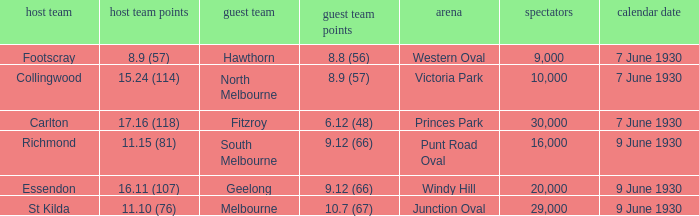Can you give me this table as a dict? {'header': ['host team', 'host team points', 'guest team', 'guest team points', 'arena', 'spectators', 'calendar date'], 'rows': [['Footscray', '8.9 (57)', 'Hawthorn', '8.8 (56)', 'Western Oval', '9,000', '7 June 1930'], ['Collingwood', '15.24 (114)', 'North Melbourne', '8.9 (57)', 'Victoria Park', '10,000', '7 June 1930'], ['Carlton', '17.16 (118)', 'Fitzroy', '6.12 (48)', 'Princes Park', '30,000', '7 June 1930'], ['Richmond', '11.15 (81)', 'South Melbourne', '9.12 (66)', 'Punt Road Oval', '16,000', '9 June 1930'], ['Essendon', '16.11 (107)', 'Geelong', '9.12 (66)', 'Windy Hill', '20,000', '9 June 1930'], ['St Kilda', '11.10 (76)', 'Melbourne', '10.7 (67)', 'Junction Oval', '29,000', '9 June 1930']]} Where did the away team score 8.9 (57)? Victoria Park. 